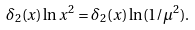Convert formula to latex. <formula><loc_0><loc_0><loc_500><loc_500>\delta _ { 2 } ( x ) \ln x ^ { 2 } = \delta _ { 2 } ( x ) \ln ( 1 / \mu ^ { 2 } ) .</formula> 